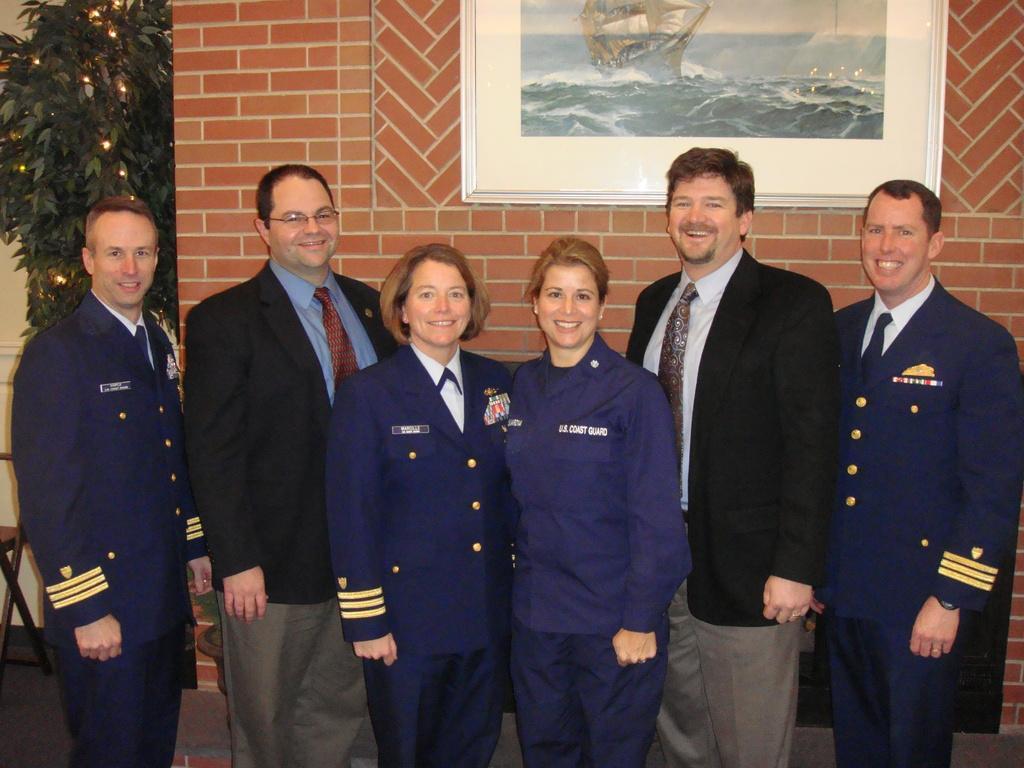Could you give a brief overview of what you see in this image? Here in this picture we can see a group of people standing on the floor over there and all of them are smiling and behind them on the wall we can see a portrait present and on the left side we can see a tree present and we can also see a chair present over there. 